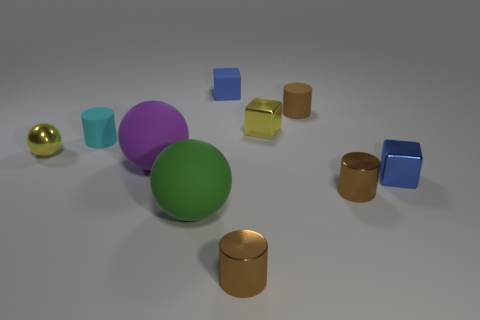What is the material of the tiny cube that is in front of the blue rubber object and behind the small cyan matte cylinder? The tiny cube positioned between the blue rubber object and the cyan matte cylinder appears to be metallic, given its reflective surface that suggests a hard, non-porous material, typical of metals. 